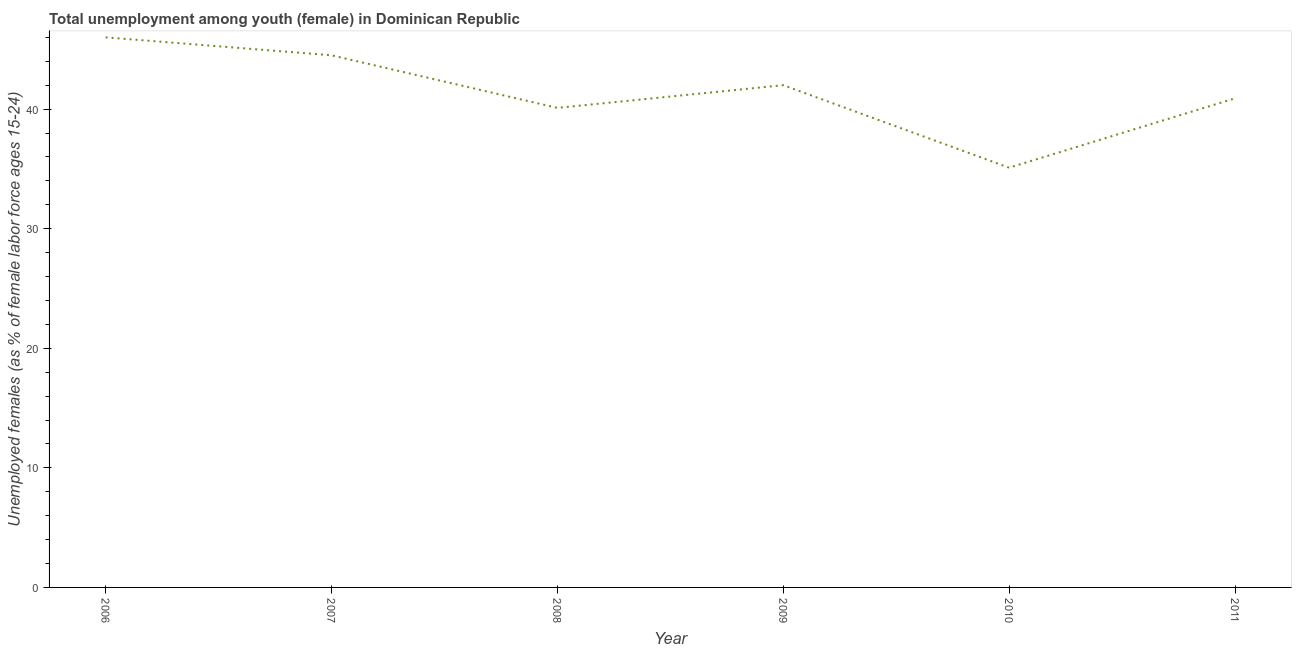What is the unemployed female youth population in 2010?
Provide a short and direct response. 35.1. Across all years, what is the maximum unemployed female youth population?
Your answer should be very brief. 46. Across all years, what is the minimum unemployed female youth population?
Your answer should be very brief. 35.1. What is the sum of the unemployed female youth population?
Your answer should be very brief. 248.6. What is the average unemployed female youth population per year?
Your answer should be compact. 41.43. What is the median unemployed female youth population?
Your answer should be very brief. 41.45. Do a majority of the years between 2011 and 2007 (inclusive) have unemployed female youth population greater than 34 %?
Provide a short and direct response. Yes. What is the ratio of the unemployed female youth population in 2006 to that in 2008?
Your answer should be very brief. 1.15. What is the difference between the highest and the second highest unemployed female youth population?
Ensure brevity in your answer.  1.5. Is the sum of the unemployed female youth population in 2007 and 2009 greater than the maximum unemployed female youth population across all years?
Offer a very short reply. Yes. What is the difference between the highest and the lowest unemployed female youth population?
Your response must be concise. 10.9. In how many years, is the unemployed female youth population greater than the average unemployed female youth population taken over all years?
Ensure brevity in your answer.  3. Does the unemployed female youth population monotonically increase over the years?
Your answer should be very brief. No. Are the values on the major ticks of Y-axis written in scientific E-notation?
Provide a short and direct response. No. Does the graph contain grids?
Keep it short and to the point. No. What is the title of the graph?
Offer a terse response. Total unemployment among youth (female) in Dominican Republic. What is the label or title of the X-axis?
Ensure brevity in your answer.  Year. What is the label or title of the Y-axis?
Offer a very short reply. Unemployed females (as % of female labor force ages 15-24). What is the Unemployed females (as % of female labor force ages 15-24) in 2006?
Make the answer very short. 46. What is the Unemployed females (as % of female labor force ages 15-24) in 2007?
Keep it short and to the point. 44.5. What is the Unemployed females (as % of female labor force ages 15-24) in 2008?
Offer a very short reply. 40.1. What is the Unemployed females (as % of female labor force ages 15-24) in 2010?
Ensure brevity in your answer.  35.1. What is the Unemployed females (as % of female labor force ages 15-24) of 2011?
Provide a short and direct response. 40.9. What is the difference between the Unemployed females (as % of female labor force ages 15-24) in 2006 and 2007?
Ensure brevity in your answer.  1.5. What is the difference between the Unemployed females (as % of female labor force ages 15-24) in 2006 and 2008?
Your answer should be very brief. 5.9. What is the difference between the Unemployed females (as % of female labor force ages 15-24) in 2006 and 2009?
Offer a very short reply. 4. What is the difference between the Unemployed females (as % of female labor force ages 15-24) in 2006 and 2010?
Offer a very short reply. 10.9. What is the difference between the Unemployed females (as % of female labor force ages 15-24) in 2007 and 2011?
Ensure brevity in your answer.  3.6. What is the difference between the Unemployed females (as % of female labor force ages 15-24) in 2008 and 2009?
Provide a succinct answer. -1.9. What is the difference between the Unemployed females (as % of female labor force ages 15-24) in 2008 and 2010?
Provide a succinct answer. 5. What is the difference between the Unemployed females (as % of female labor force ages 15-24) in 2008 and 2011?
Your answer should be very brief. -0.8. What is the difference between the Unemployed females (as % of female labor force ages 15-24) in 2009 and 2011?
Give a very brief answer. 1.1. What is the difference between the Unemployed females (as % of female labor force ages 15-24) in 2010 and 2011?
Ensure brevity in your answer.  -5.8. What is the ratio of the Unemployed females (as % of female labor force ages 15-24) in 2006 to that in 2007?
Provide a succinct answer. 1.03. What is the ratio of the Unemployed females (as % of female labor force ages 15-24) in 2006 to that in 2008?
Offer a terse response. 1.15. What is the ratio of the Unemployed females (as % of female labor force ages 15-24) in 2006 to that in 2009?
Offer a very short reply. 1.09. What is the ratio of the Unemployed females (as % of female labor force ages 15-24) in 2006 to that in 2010?
Provide a succinct answer. 1.31. What is the ratio of the Unemployed females (as % of female labor force ages 15-24) in 2006 to that in 2011?
Your response must be concise. 1.12. What is the ratio of the Unemployed females (as % of female labor force ages 15-24) in 2007 to that in 2008?
Keep it short and to the point. 1.11. What is the ratio of the Unemployed females (as % of female labor force ages 15-24) in 2007 to that in 2009?
Ensure brevity in your answer.  1.06. What is the ratio of the Unemployed females (as % of female labor force ages 15-24) in 2007 to that in 2010?
Your answer should be compact. 1.27. What is the ratio of the Unemployed females (as % of female labor force ages 15-24) in 2007 to that in 2011?
Your answer should be very brief. 1.09. What is the ratio of the Unemployed females (as % of female labor force ages 15-24) in 2008 to that in 2009?
Keep it short and to the point. 0.95. What is the ratio of the Unemployed females (as % of female labor force ages 15-24) in 2008 to that in 2010?
Your answer should be very brief. 1.14. What is the ratio of the Unemployed females (as % of female labor force ages 15-24) in 2008 to that in 2011?
Ensure brevity in your answer.  0.98. What is the ratio of the Unemployed females (as % of female labor force ages 15-24) in 2009 to that in 2010?
Keep it short and to the point. 1.2. What is the ratio of the Unemployed females (as % of female labor force ages 15-24) in 2010 to that in 2011?
Keep it short and to the point. 0.86. 